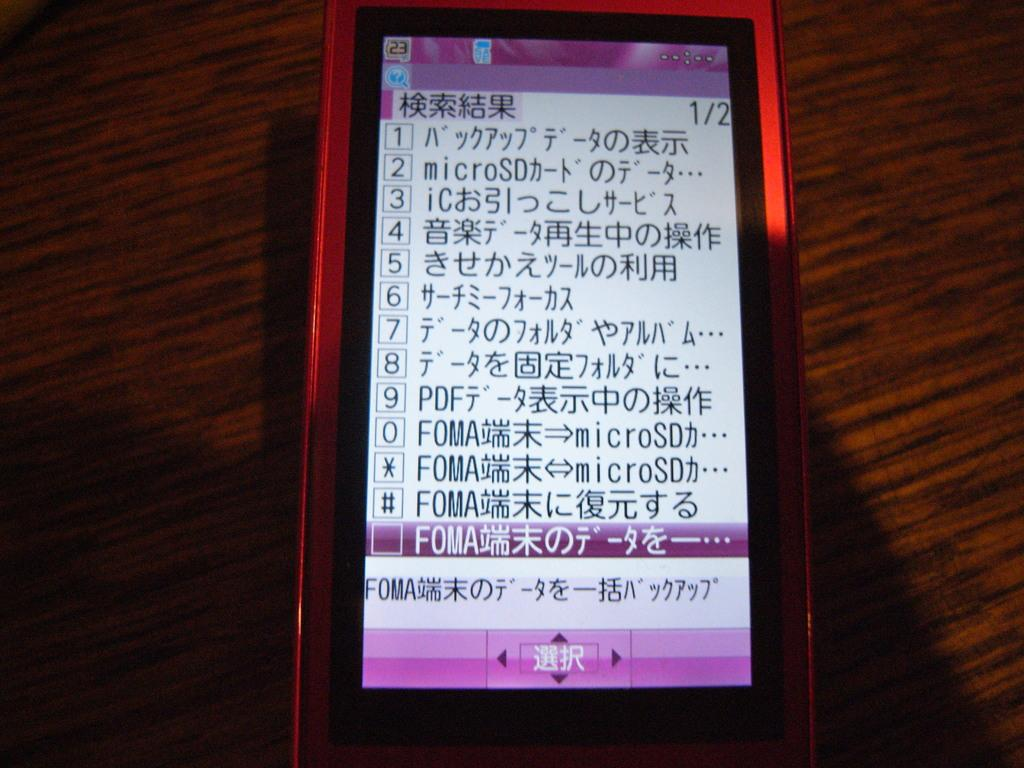<image>
Render a clear and concise summary of the photo. Foreign writing on a cellphone with numbers, Foma, MicroSd and Foma. 